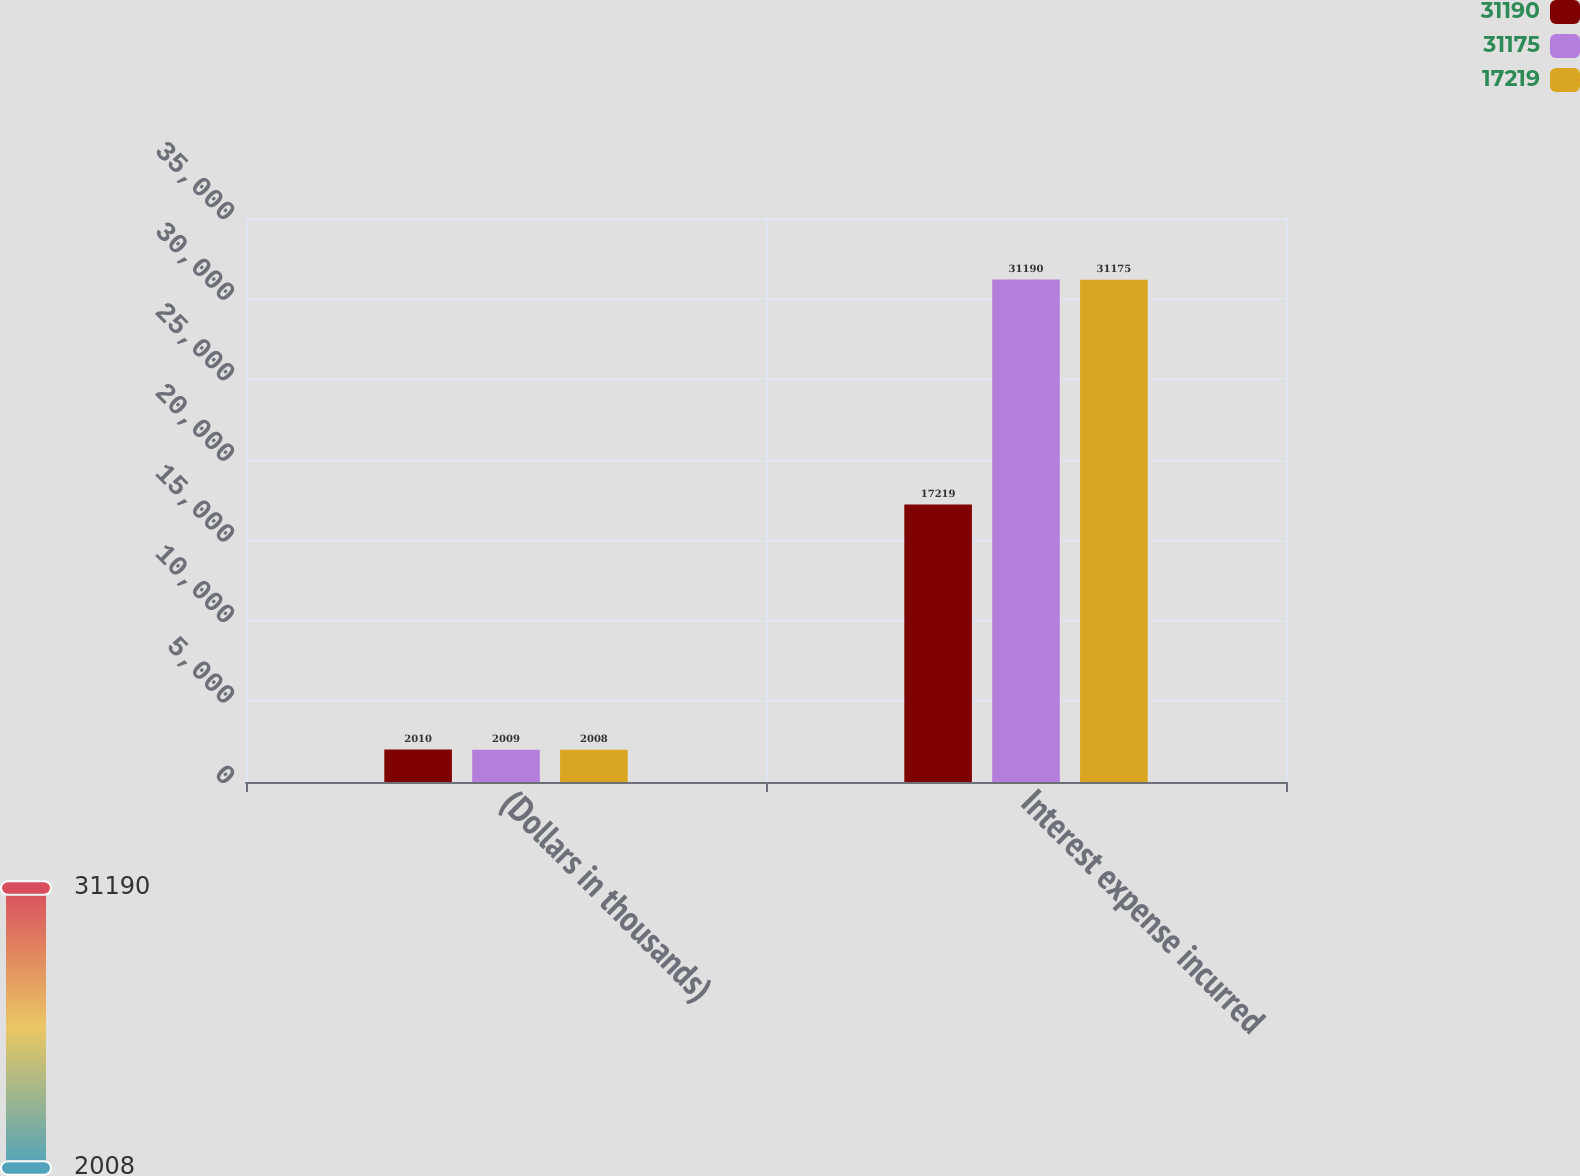<chart> <loc_0><loc_0><loc_500><loc_500><stacked_bar_chart><ecel><fcel>(Dollars in thousands)<fcel>Interest expense incurred<nl><fcel>31190<fcel>2010<fcel>17219<nl><fcel>31175<fcel>2009<fcel>31190<nl><fcel>17219<fcel>2008<fcel>31175<nl></chart> 